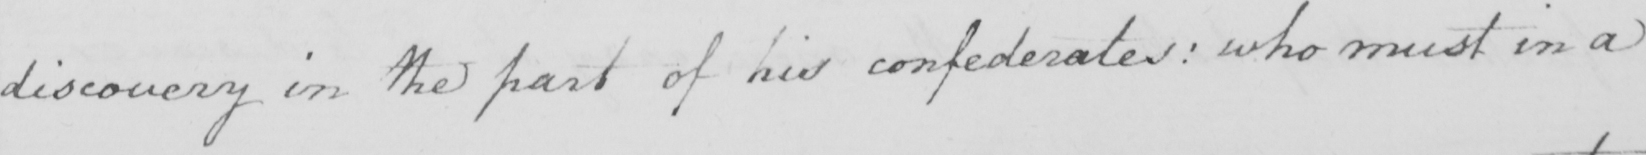What text is written in this handwritten line? discovery in the part of his confederates :  who must in a 